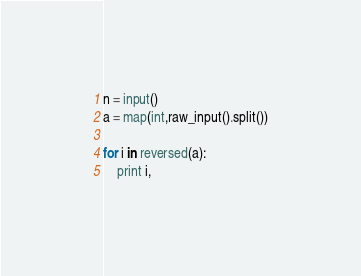<code> <loc_0><loc_0><loc_500><loc_500><_Python_>n = input()
a = map(int,raw_input().split())

for i in reversed(a):
    print i, </code> 